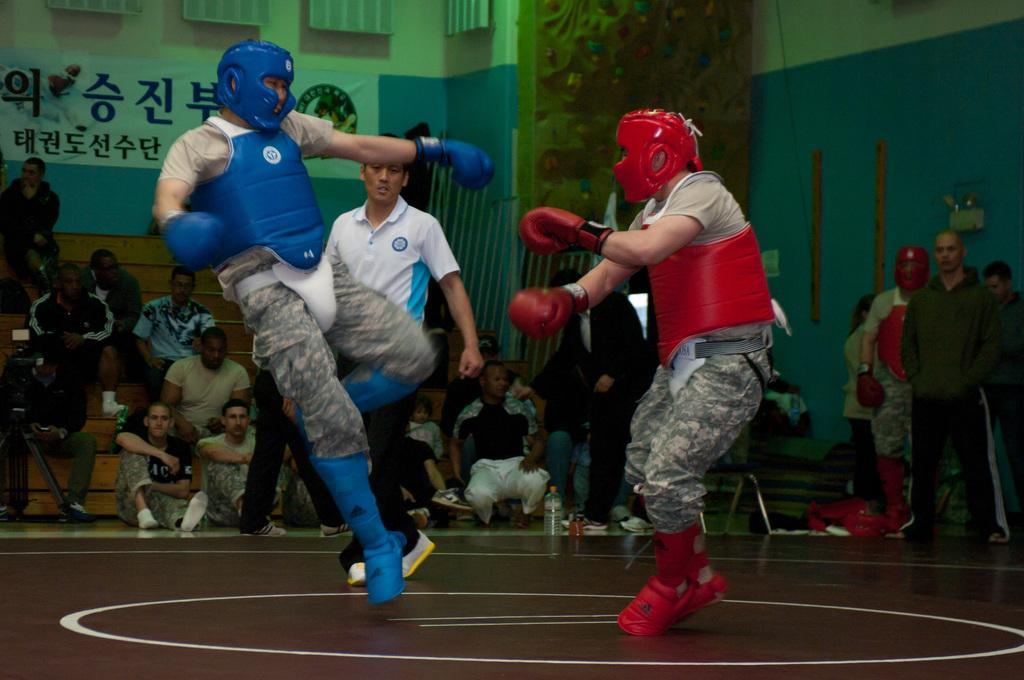Could you give a brief overview of what you see in this image? In the image there are two people boxing with each other and behind them there are a group of people, in the background there is a wall and there is some banner kept in front of the wall. 